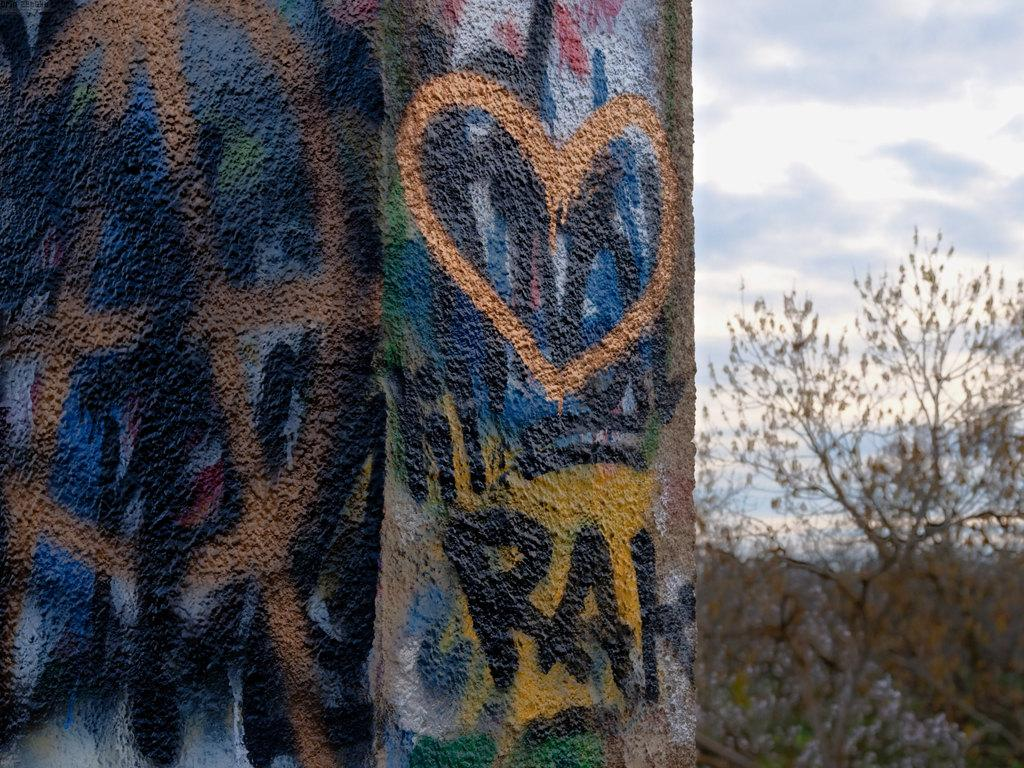What is located on the left side of the image? There is a wall on the left side of the image. What is depicted on the wall? A painting is done on the wall. What type of vegetation is on the right side of the image? There is a tree on the right side of the image. What is visible at the top of the image? The sky is visible in the image. What is the rate of the rubbing sound coming from the zoo in the image? There is no zoo or rubbing sound present in the image. What type of creature is shown interacting with the tree on the right side of the image? There is no creature shown interacting with the tree on the right side of the image; only the tree is present. 